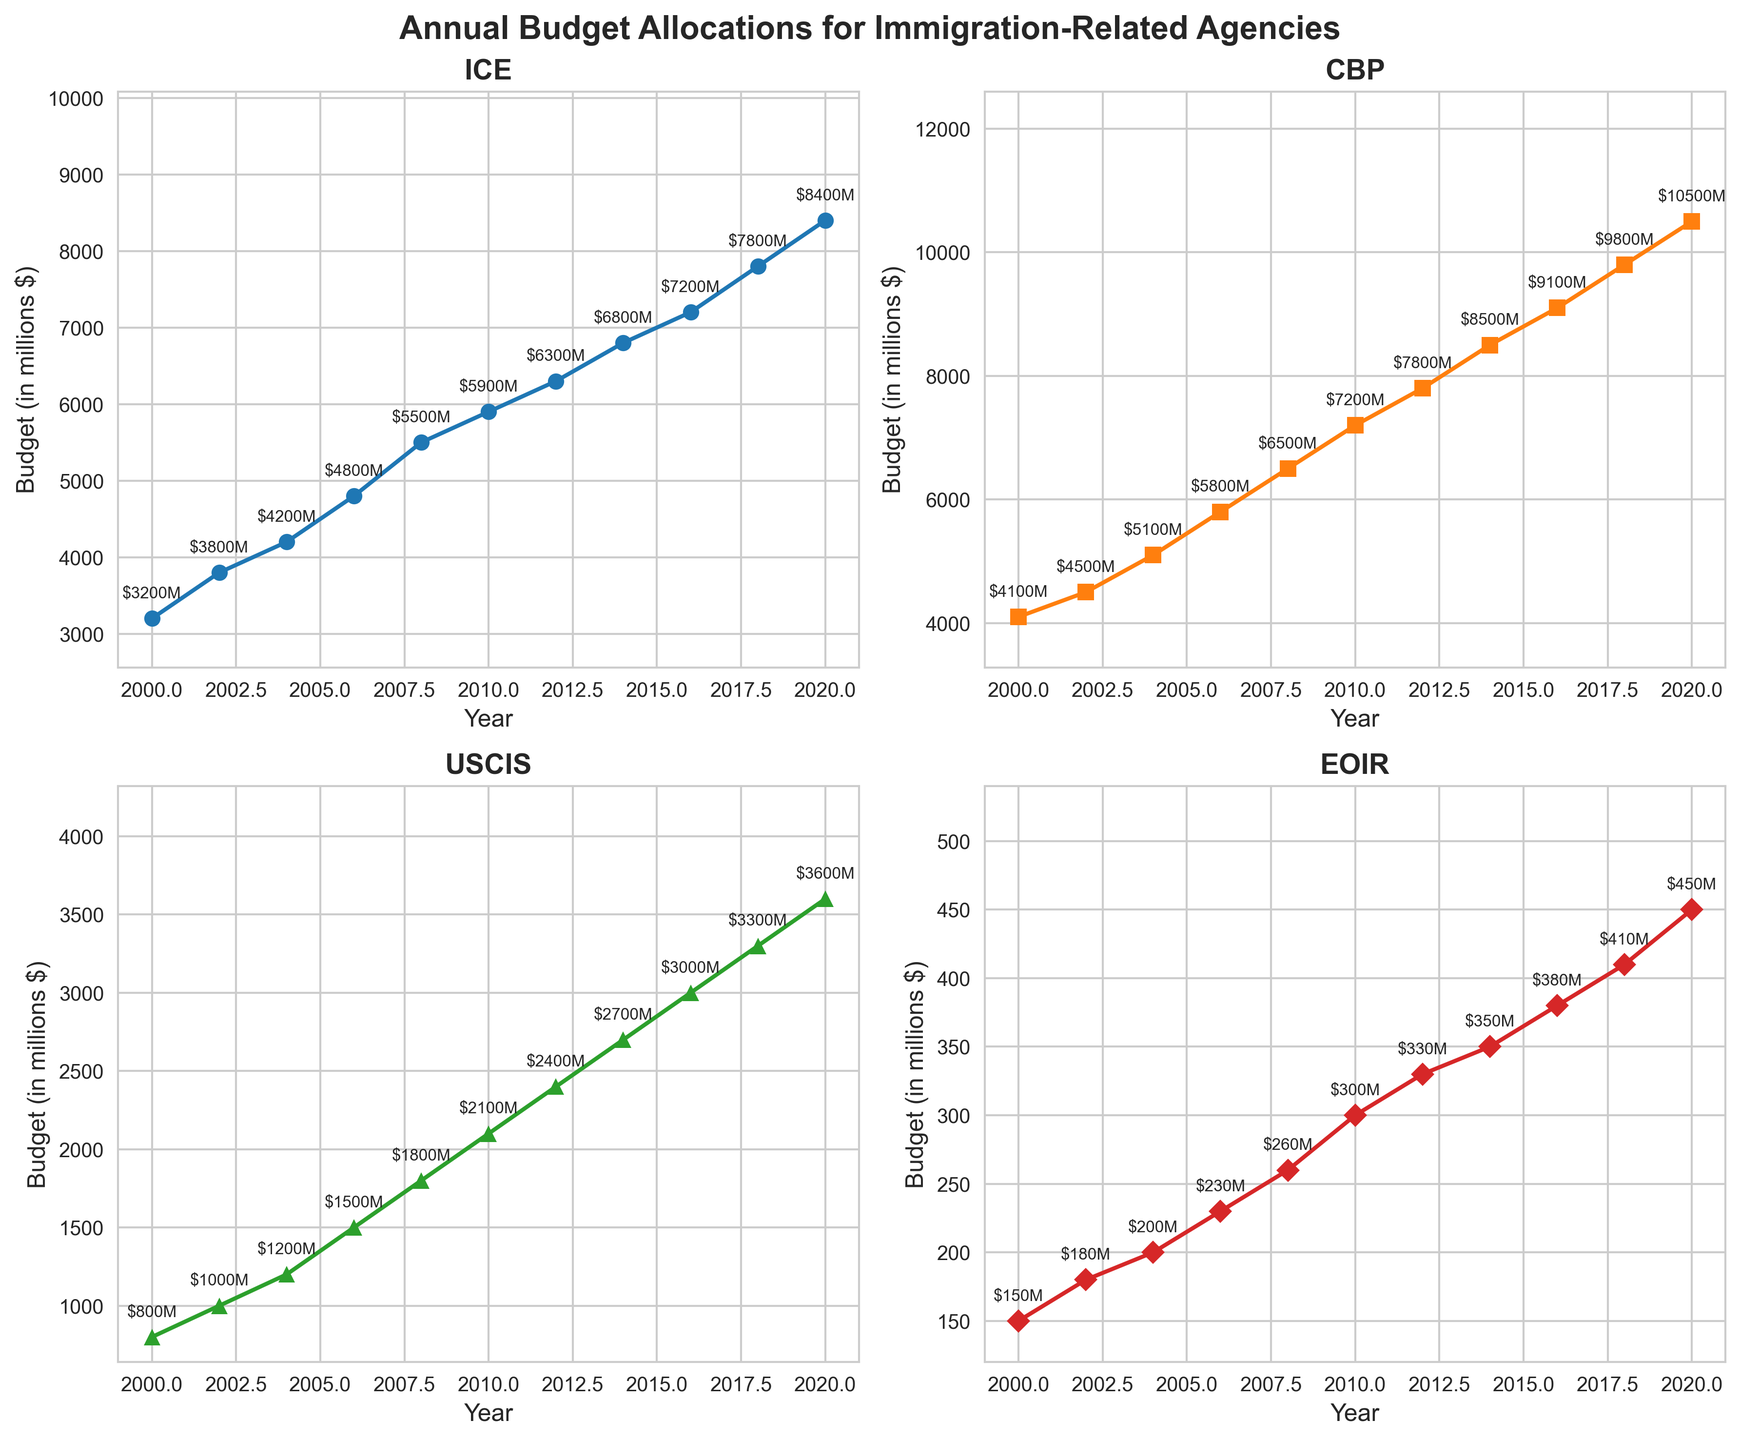How many different agencies' budget allocations are shown in the figure? The figure shows four subplots with titles representing the different agencies. Each subplot corresponds to one agency: ICE, CBP, USCIS, and EOIR.
Answer: 4 What is the title of the figure? The title of the figure is displayed at the top of the figure in bold font.
Answer: Annual Budget Allocations for Immigration-Related Agencies Which agency had the highest budget allocation in 2020? Look at all four subplots and compare the budget values for the year 2020. The highest value is for CBP with a budget of 10,500 million dollars.
Answer: CBP What's the average budget allocation for USCIS across all years shown? To calculate the average, sum all the USCIS budget values and divide by the number of data points. The values are 800, 1000, 1200, 1500, 1800, 2100, 2400, 2700, 3000, 3300, and 3600. (800+1000+1200+1500+1800+2100+2400+2700+3000+3300+3600) / 11 = 1981.8
Answer: 1981.8 How did the EOIR budget allocation change from 2018 to 2020? Compare the EOIR budget values for the years 2018 and 2020. The budget in 2018 was 410 million dollars, and it increased to 450 million dollars in 2020.
Answer: Increased by 40 million dollars Which agency had the least total growth in budget allocations from 2000 to 2020? Calculate the difference in budget values for 2020 and 2000 for each agency. ICE: 8400 - 3200 = 5200, CBP: 10500 - 4100 = 6400, USCIS: 3600 - 800 = 2800, EOIR: 450 - 150 = 300. The least growth is for EOIR with 300 million dollars.
Answer: EOIR Between which two consecutive years did the ICE budget see the largest increase? Calculate the differences in budget values for each consecutive pair of years and identify the largest. The differences are: 2000-2002: 600, 2002-2004: 400, 2004-2006: 600, 2006-2008: 700, 2008-2010: 400, 2010-2012: 400, 2012-2014: 500, 2014-2016: 400, 2016-2018: 600, 2018-2020: 600. The largest increase occurred between 2006-2008 with 700 million dollars.
Answer: 2006-2008 In which year did CBP's budget first exceed 9000 million dollars? Look at the CBP subplot and identify the first year when the budget value exceeded 9000 million dollars. This occurred in 2016.
Answer: 2016 Is the trend of budgeting increasing, decreasing, or stable for each agency since 2000? Observe each subplot: the budgets for ICE, CBP, USCIS, and EOIR all show an increasing trend over the years.
Answer: Increasing 